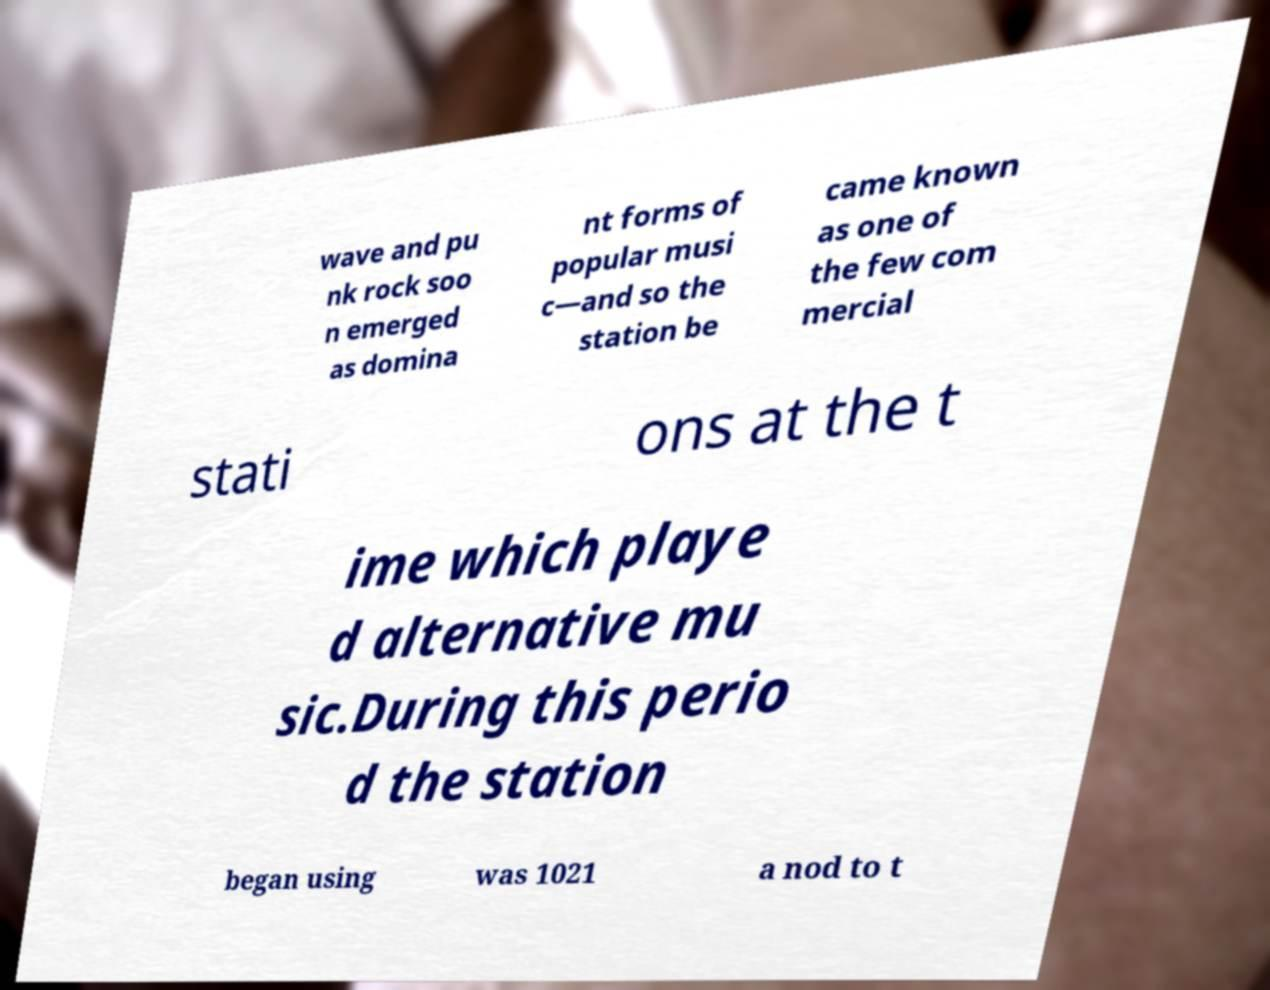Can you read and provide the text displayed in the image?This photo seems to have some interesting text. Can you extract and type it out for me? wave and pu nk rock soo n emerged as domina nt forms of popular musi c—and so the station be came known as one of the few com mercial stati ons at the t ime which playe d alternative mu sic.During this perio d the station began using was 1021 a nod to t 